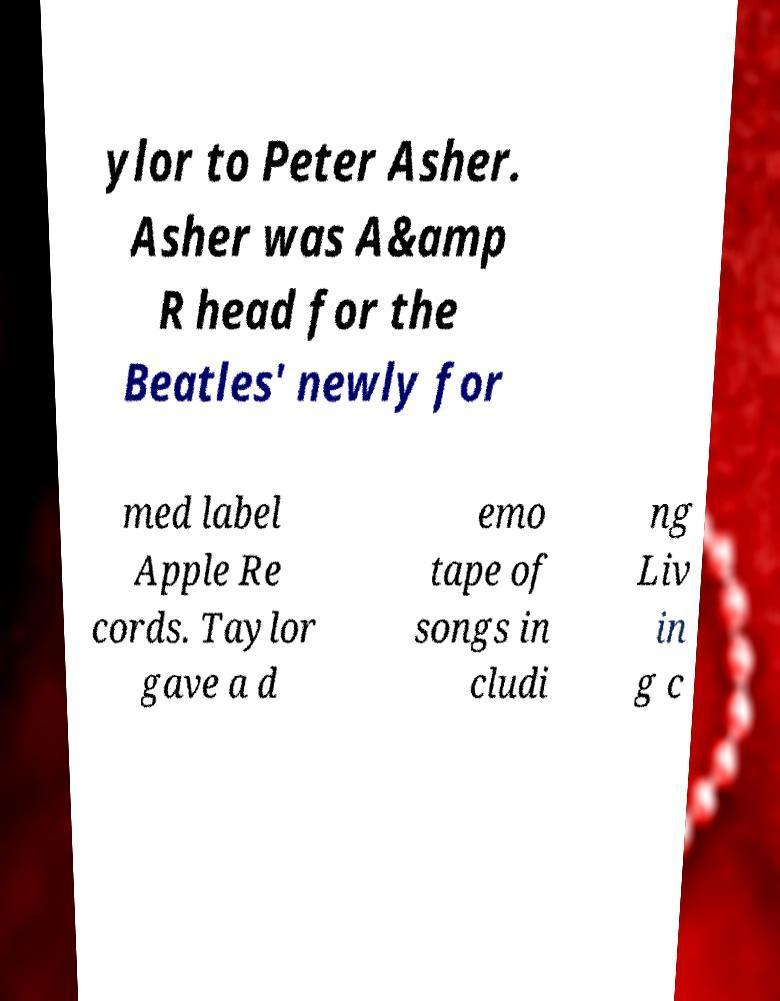There's text embedded in this image that I need extracted. Can you transcribe it verbatim? ylor to Peter Asher. Asher was A&amp R head for the Beatles' newly for med label Apple Re cords. Taylor gave a d emo tape of songs in cludi ng Liv in g c 